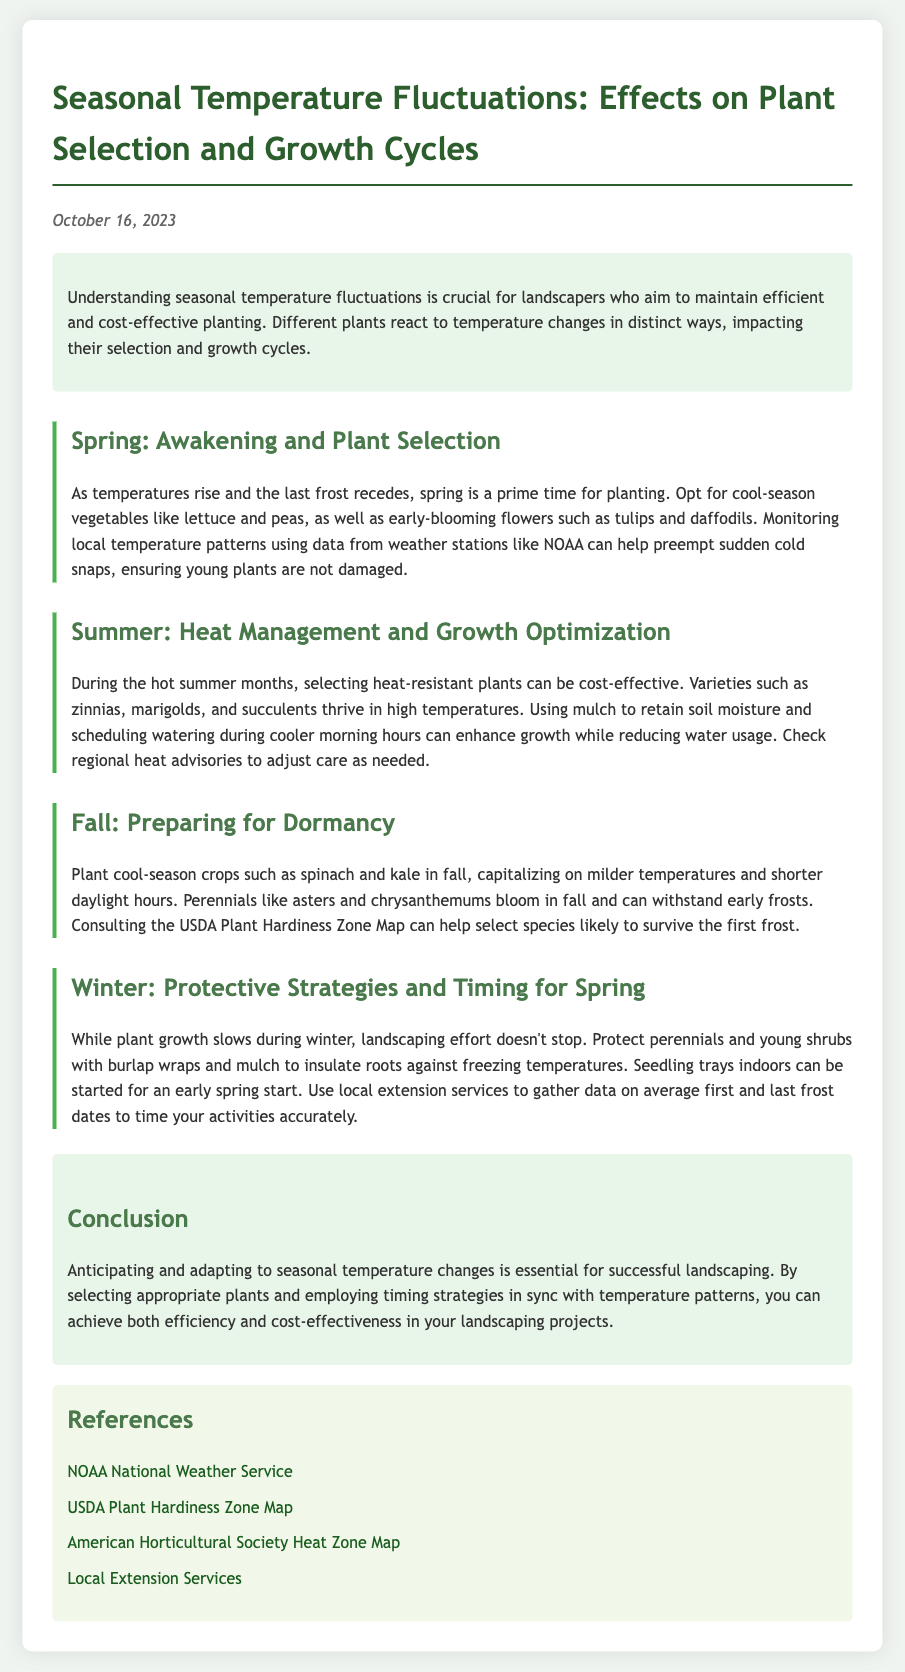What is the date of the report? The report is dated October 16, 2023, as indicated at the top of the document.
Answer: October 16, 2023 What plants are suggested for spring planting? The document suggests cool-season vegetables like lettuce and peas, as well as early-blooming flowers such as tulips and daffodils for spring planting.
Answer: Lettuce, peas, tulips, daffodils What should be used in summer to enhance growth? Using mulch is suggested to retain soil moisture during the hot summer months.
Answer: Mulch Which crops should be planted in fall? Cool-season crops such as spinach and kale are recommended to be planted in fall according to the document.
Answer: Spinach, kale What wrapping material can protect perennials in winter? The document states that burlap wraps can be used to protect perennials against freezing temperatures in winter.
Answer: Burlap What is essential for successful landscaping? Anticipating and adapting to seasonal temperature changes is identified as essential for successful landscaping in the conclusion section.
Answer: Anticipating and adapting What resource can help select species for frost survival? The USDA Plant Hardiness Zone Map is mentioned as a resource to help select species likely to survive the first frost.
Answer: USDA Plant Hardiness Zone Map What is a key strategy for summer heat management? The document suggests selecting heat-resistant plants as a key strategy for managing summer heat.
Answer: Heat-resistant plants What can seedling trays be used for in winter? Seedling trays can be started indoors for an early spring start during winter months.
Answer: Early spring start 